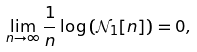<formula> <loc_0><loc_0><loc_500><loc_500>\lim _ { n \rightarrow \infty } \frac { 1 } { n } \log \left ( \mathcal { N } _ { 1 } [ n ] \right ) = 0 ,</formula> 